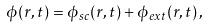Convert formula to latex. <formula><loc_0><loc_0><loc_500><loc_500>\phi ( { r } , t ) = \phi _ { s c } ( { r } , t ) + \phi _ { e x t } ( { r } , t ) \, ,</formula> 